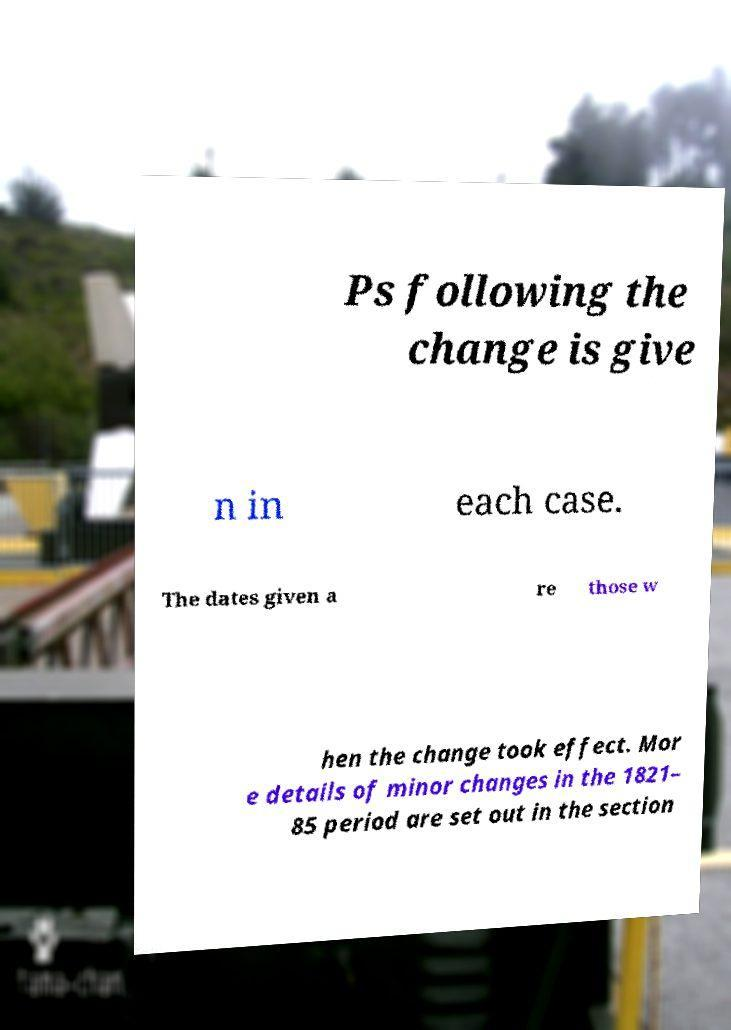Could you extract and type out the text from this image? Ps following the change is give n in each case. The dates given a re those w hen the change took effect. Mor e details of minor changes in the 1821– 85 period are set out in the section 